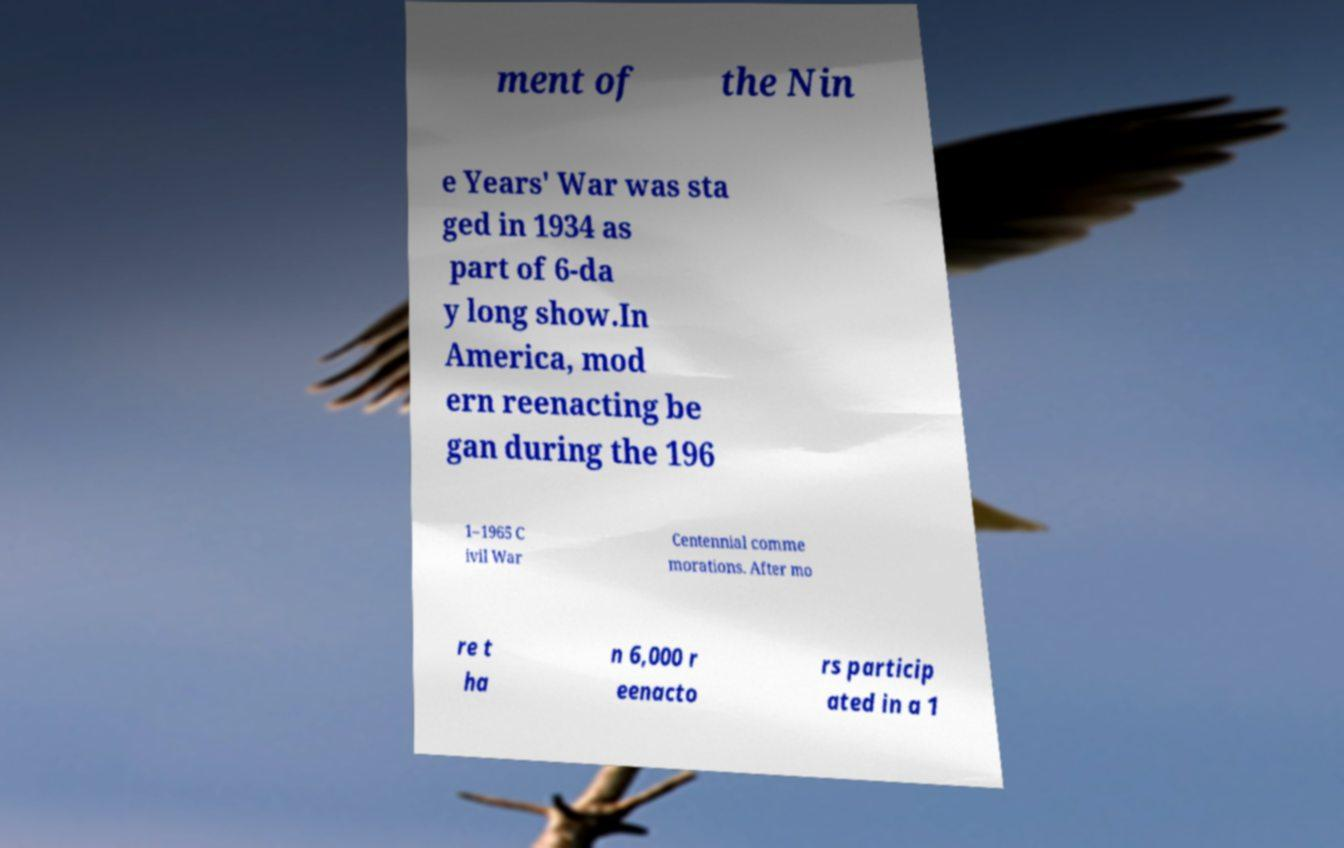Can you accurately transcribe the text from the provided image for me? ment of the Nin e Years' War was sta ged in 1934 as part of 6-da y long show.In America, mod ern reenacting be gan during the 196 1–1965 C ivil War Centennial comme morations. After mo re t ha n 6,000 r eenacto rs particip ated in a 1 